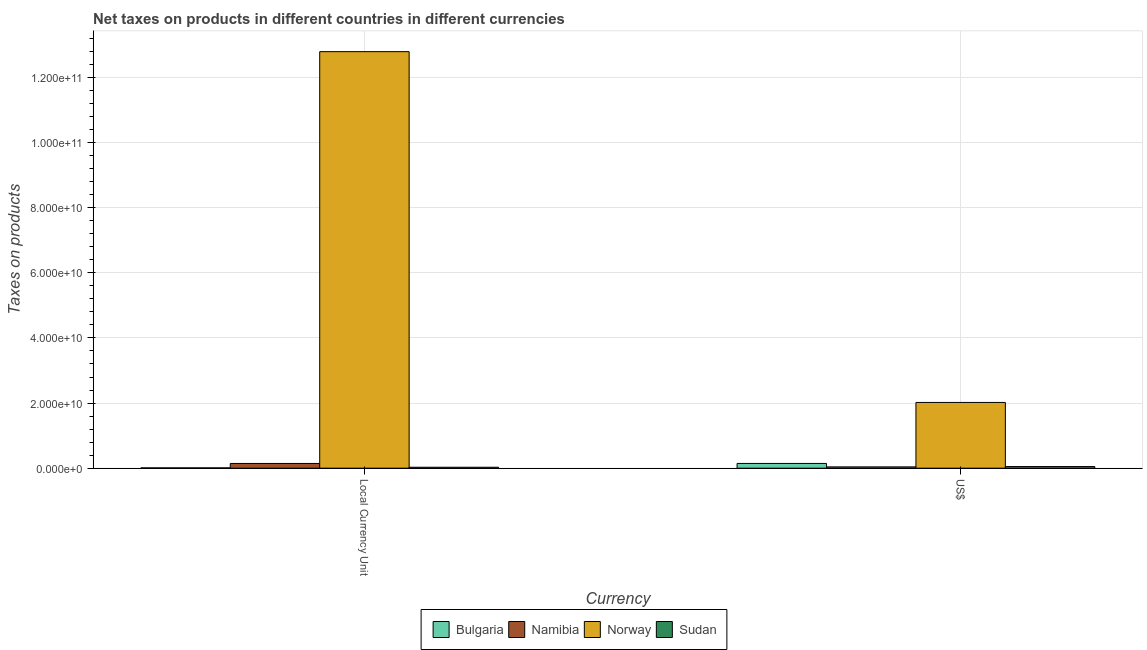How many different coloured bars are there?
Keep it short and to the point. 4. How many groups of bars are there?
Offer a terse response. 2. Are the number of bars per tick equal to the number of legend labels?
Provide a short and direct response. Yes. What is the label of the 2nd group of bars from the left?
Offer a terse response. US$. What is the net taxes in constant 2005 us$ in Norway?
Offer a very short reply. 1.28e+11. Across all countries, what is the maximum net taxes in constant 2005 us$?
Provide a short and direct response. 1.28e+11. Across all countries, what is the minimum net taxes in us$?
Provide a short and direct response. 4.01e+08. In which country was the net taxes in constant 2005 us$ maximum?
Offer a very short reply. Norway. What is the total net taxes in constant 2005 us$ in the graph?
Provide a short and direct response. 1.30e+11. What is the difference between the net taxes in constant 2005 us$ in Bulgaria and that in Sudan?
Your answer should be very brief. -1.92e+08. What is the difference between the net taxes in us$ in Bulgaria and the net taxes in constant 2005 us$ in Norway?
Your answer should be compact. -1.26e+11. What is the average net taxes in constant 2005 us$ per country?
Provide a short and direct response. 3.24e+1. What is the difference between the net taxes in constant 2005 us$ and net taxes in us$ in Norway?
Offer a very short reply. 1.08e+11. What is the ratio of the net taxes in constant 2005 us$ in Sudan to that in Namibia?
Your answer should be compact. 0.2. In how many countries, is the net taxes in constant 2005 us$ greater than the average net taxes in constant 2005 us$ taken over all countries?
Make the answer very short. 1. What does the 3rd bar from the right in US$ represents?
Keep it short and to the point. Namibia. How many bars are there?
Offer a very short reply. 8. Are all the bars in the graph horizontal?
Your answer should be very brief. No. Does the graph contain any zero values?
Offer a very short reply. No. How many legend labels are there?
Your response must be concise. 4. What is the title of the graph?
Make the answer very short. Net taxes on products in different countries in different currencies. Does "Cameroon" appear as one of the legend labels in the graph?
Your answer should be compact. No. What is the label or title of the X-axis?
Ensure brevity in your answer.  Currency. What is the label or title of the Y-axis?
Make the answer very short. Taxes on products. What is the Taxes on products of Bulgaria in Local Currency Unit?
Provide a short and direct response. 9.79e+07. What is the Taxes on products in Namibia in Local Currency Unit?
Give a very brief answer. 1.46e+09. What is the Taxes on products of Norway in Local Currency Unit?
Provide a short and direct response. 1.28e+11. What is the Taxes on products of Sudan in Local Currency Unit?
Offer a very short reply. 2.90e+08. What is the Taxes on products of Bulgaria in US$?
Your answer should be compact. 1.46e+09. What is the Taxes on products of Namibia in US$?
Your answer should be compact. 4.01e+08. What is the Taxes on products in Norway in US$?
Provide a succinct answer. 2.02e+1. What is the Taxes on products in Sudan in US$?
Provide a short and direct response. 4.99e+08. Across all Currency, what is the maximum Taxes on products of Bulgaria?
Your response must be concise. 1.46e+09. Across all Currency, what is the maximum Taxes on products in Namibia?
Offer a terse response. 1.46e+09. Across all Currency, what is the maximum Taxes on products in Norway?
Make the answer very short. 1.28e+11. Across all Currency, what is the maximum Taxes on products in Sudan?
Your answer should be compact. 4.99e+08. Across all Currency, what is the minimum Taxes on products in Bulgaria?
Provide a short and direct response. 9.79e+07. Across all Currency, what is the minimum Taxes on products in Namibia?
Your answer should be compact. 4.01e+08. Across all Currency, what is the minimum Taxes on products of Norway?
Ensure brevity in your answer.  2.02e+1. Across all Currency, what is the minimum Taxes on products of Sudan?
Offer a very short reply. 2.90e+08. What is the total Taxes on products of Bulgaria in the graph?
Offer a very short reply. 1.56e+09. What is the total Taxes on products in Namibia in the graph?
Make the answer very short. 1.86e+09. What is the total Taxes on products in Norway in the graph?
Keep it short and to the point. 1.48e+11. What is the total Taxes on products in Sudan in the graph?
Make the answer very short. 7.88e+08. What is the difference between the Taxes on products of Bulgaria in Local Currency Unit and that in US$?
Provide a short and direct response. -1.36e+09. What is the difference between the Taxes on products in Namibia in Local Currency Unit and that in US$?
Your answer should be very brief. 1.05e+09. What is the difference between the Taxes on products in Norway in Local Currency Unit and that in US$?
Make the answer very short. 1.08e+11. What is the difference between the Taxes on products in Sudan in Local Currency Unit and that in US$?
Make the answer very short. -2.09e+08. What is the difference between the Taxes on products in Bulgaria in Local Currency Unit and the Taxes on products in Namibia in US$?
Keep it short and to the point. -3.03e+08. What is the difference between the Taxes on products in Bulgaria in Local Currency Unit and the Taxes on products in Norway in US$?
Keep it short and to the point. -2.01e+1. What is the difference between the Taxes on products of Bulgaria in Local Currency Unit and the Taxes on products of Sudan in US$?
Your response must be concise. -4.01e+08. What is the difference between the Taxes on products in Namibia in Local Currency Unit and the Taxes on products in Norway in US$?
Your answer should be compact. -1.87e+1. What is the difference between the Taxes on products of Namibia in Local Currency Unit and the Taxes on products of Sudan in US$?
Give a very brief answer. 9.57e+08. What is the difference between the Taxes on products in Norway in Local Currency Unit and the Taxes on products in Sudan in US$?
Ensure brevity in your answer.  1.27e+11. What is the average Taxes on products in Bulgaria per Currency?
Provide a short and direct response. 7.78e+08. What is the average Taxes on products in Namibia per Currency?
Ensure brevity in your answer.  9.28e+08. What is the average Taxes on products in Norway per Currency?
Your answer should be compact. 7.41e+1. What is the average Taxes on products of Sudan per Currency?
Provide a short and direct response. 3.94e+08. What is the difference between the Taxes on products of Bulgaria and Taxes on products of Namibia in Local Currency Unit?
Your answer should be compact. -1.36e+09. What is the difference between the Taxes on products of Bulgaria and Taxes on products of Norway in Local Currency Unit?
Ensure brevity in your answer.  -1.28e+11. What is the difference between the Taxes on products of Bulgaria and Taxes on products of Sudan in Local Currency Unit?
Your response must be concise. -1.92e+08. What is the difference between the Taxes on products in Namibia and Taxes on products in Norway in Local Currency Unit?
Offer a terse response. -1.26e+11. What is the difference between the Taxes on products in Namibia and Taxes on products in Sudan in Local Currency Unit?
Your answer should be very brief. 1.17e+09. What is the difference between the Taxes on products of Norway and Taxes on products of Sudan in Local Currency Unit?
Make the answer very short. 1.28e+11. What is the difference between the Taxes on products of Bulgaria and Taxes on products of Namibia in US$?
Offer a terse response. 1.06e+09. What is the difference between the Taxes on products of Bulgaria and Taxes on products of Norway in US$?
Offer a very short reply. -1.87e+1. What is the difference between the Taxes on products in Bulgaria and Taxes on products in Sudan in US$?
Offer a very short reply. 9.59e+08. What is the difference between the Taxes on products in Namibia and Taxes on products in Norway in US$?
Your answer should be compact. -1.98e+1. What is the difference between the Taxes on products of Namibia and Taxes on products of Sudan in US$?
Provide a succinct answer. -9.74e+07. What is the difference between the Taxes on products of Norway and Taxes on products of Sudan in US$?
Give a very brief answer. 1.97e+1. What is the ratio of the Taxes on products of Bulgaria in Local Currency Unit to that in US$?
Your response must be concise. 0.07. What is the ratio of the Taxes on products of Namibia in Local Currency Unit to that in US$?
Your response must be concise. 3.63. What is the ratio of the Taxes on products of Norway in Local Currency Unit to that in US$?
Give a very brief answer. 6.34. What is the ratio of the Taxes on products in Sudan in Local Currency Unit to that in US$?
Keep it short and to the point. 0.58. What is the difference between the highest and the second highest Taxes on products in Bulgaria?
Give a very brief answer. 1.36e+09. What is the difference between the highest and the second highest Taxes on products in Namibia?
Offer a terse response. 1.05e+09. What is the difference between the highest and the second highest Taxes on products in Norway?
Provide a short and direct response. 1.08e+11. What is the difference between the highest and the second highest Taxes on products of Sudan?
Give a very brief answer. 2.09e+08. What is the difference between the highest and the lowest Taxes on products in Bulgaria?
Keep it short and to the point. 1.36e+09. What is the difference between the highest and the lowest Taxes on products in Namibia?
Offer a terse response. 1.05e+09. What is the difference between the highest and the lowest Taxes on products in Norway?
Keep it short and to the point. 1.08e+11. What is the difference between the highest and the lowest Taxes on products of Sudan?
Provide a short and direct response. 2.09e+08. 